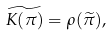Convert formula to latex. <formula><loc_0><loc_0><loc_500><loc_500>\widetilde { K ( \pi ) } = \rho ( \widetilde { \pi } ) ,</formula> 